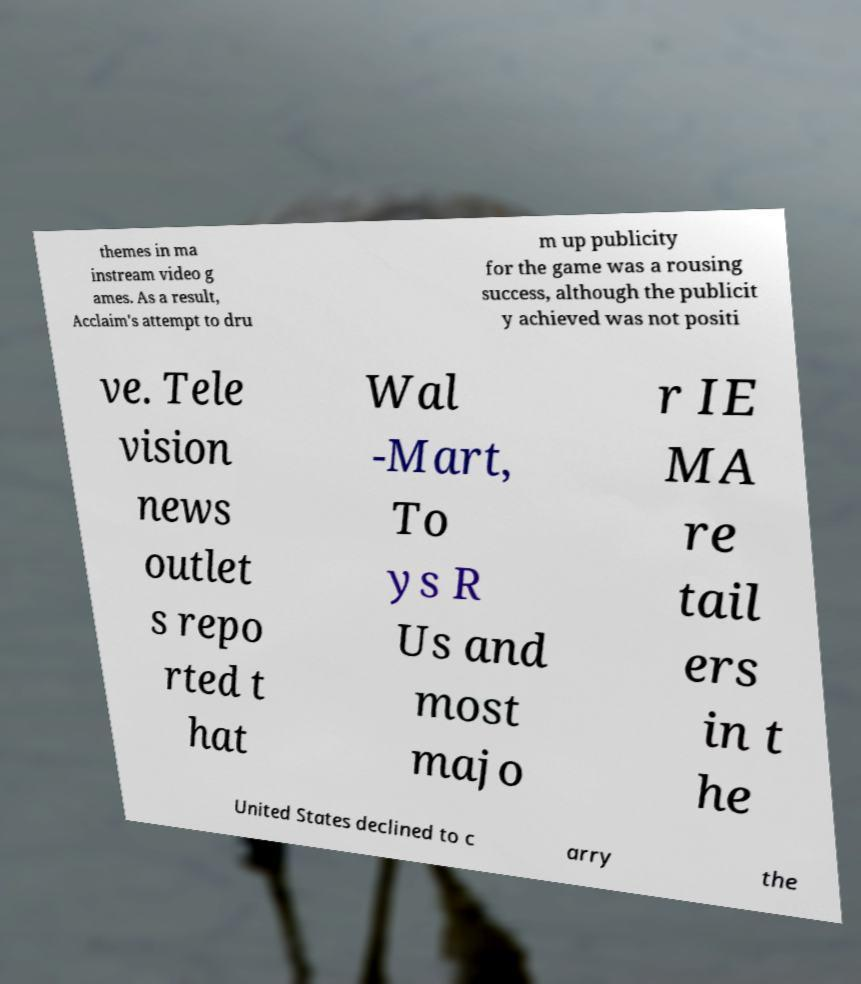Please read and relay the text visible in this image. What does it say? themes in ma instream video g ames. As a result, Acclaim's attempt to dru m up publicity for the game was a rousing success, although the publicit y achieved was not positi ve. Tele vision news outlet s repo rted t hat Wal -Mart, To ys R Us and most majo r IE MA re tail ers in t he United States declined to c arry the 